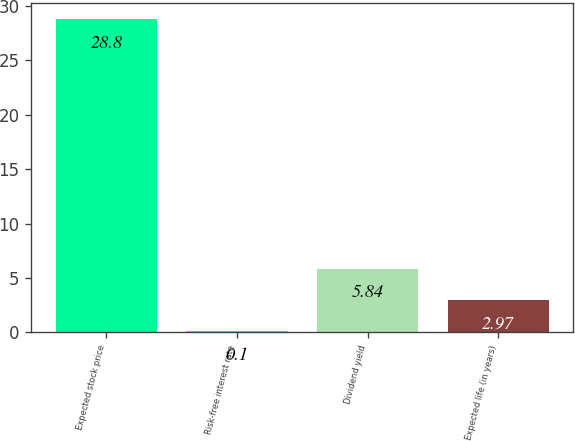Convert chart to OTSL. <chart><loc_0><loc_0><loc_500><loc_500><bar_chart><fcel>Expected stock price<fcel>Risk-free interest rate<fcel>Dividend yield<fcel>Expected life (in years)<nl><fcel>28.8<fcel>0.1<fcel>5.84<fcel>2.97<nl></chart> 